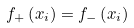Convert formula to latex. <formula><loc_0><loc_0><loc_500><loc_500>f _ { + } \left ( x _ { i } \right ) = f _ { - } \left ( x _ { i } \right )</formula> 